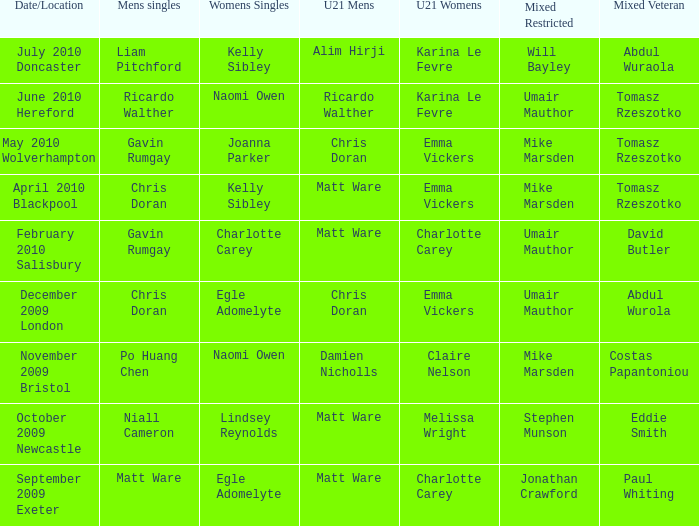Upon naomi owen's victory in the womens singles and ricardo walther's in the mens singles, who claimed the mixed veteran title? Tomasz Rzeszotko. 